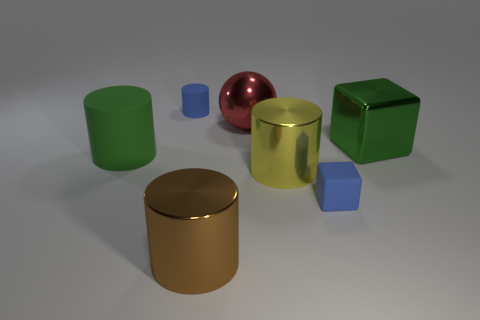What could be the purpose of these objects arranged in this manner? The arrangement of the objects doesn't appear to serve a practical function. It's possible that the image is a display or a setup designed to showcase a variety of geometric shapes and colors. It might be used as a visual aid in an educational context to teach about geometry, colors, and materials, or as an artistic composition focusing on the interplay of shapes and light. 